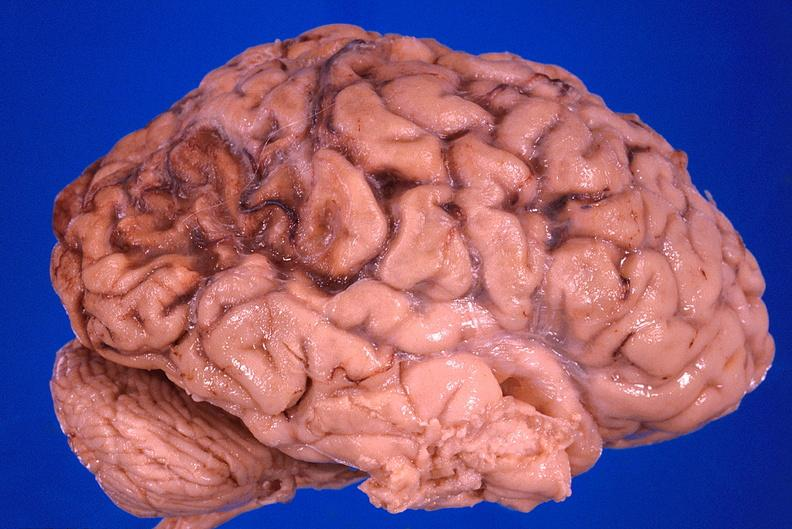does face show brain, old infarcts, embolic?
Answer the question using a single word or phrase. No 